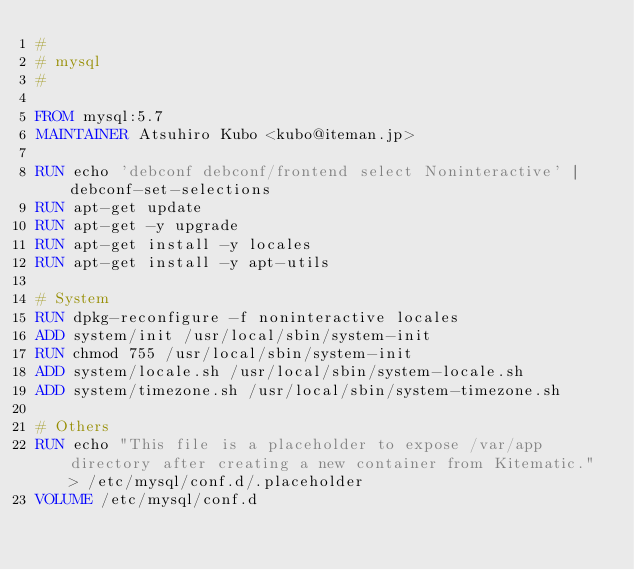<code> <loc_0><loc_0><loc_500><loc_500><_Dockerfile_>#
# mysql
#

FROM mysql:5.7
MAINTAINER Atsuhiro Kubo <kubo@iteman.jp>

RUN echo 'debconf debconf/frontend select Noninteractive' | debconf-set-selections
RUN apt-get update
RUN apt-get -y upgrade
RUN apt-get install -y locales
RUN apt-get install -y apt-utils

# System
RUN dpkg-reconfigure -f noninteractive locales
ADD system/init /usr/local/sbin/system-init
RUN chmod 755 /usr/local/sbin/system-init
ADD system/locale.sh /usr/local/sbin/system-locale.sh
ADD system/timezone.sh /usr/local/sbin/system-timezone.sh

# Others
RUN echo "This file is a placeholder to expose /var/app directory after creating a new container from Kitematic." > /etc/mysql/conf.d/.placeholder
VOLUME /etc/mysql/conf.d
</code> 